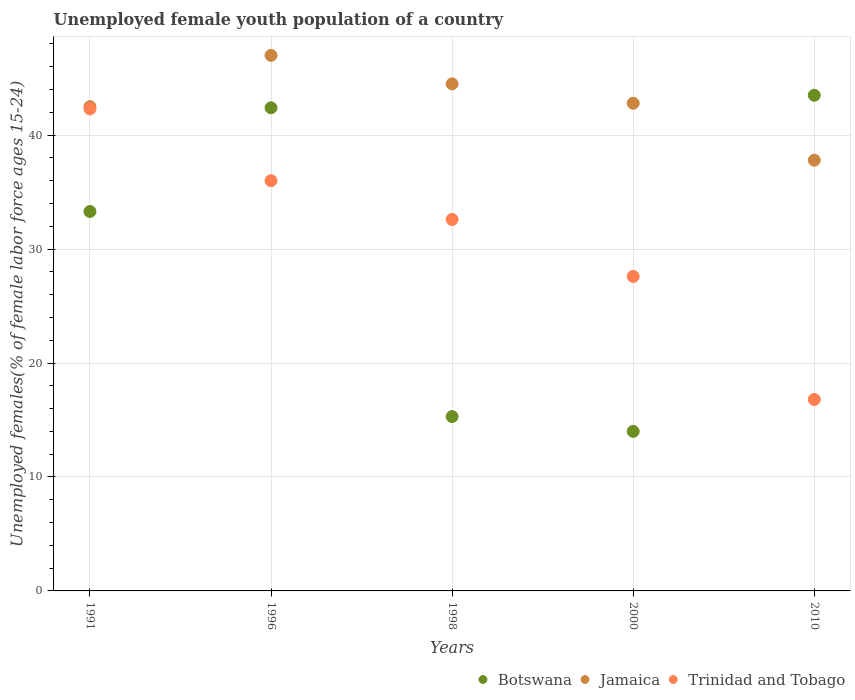Is the number of dotlines equal to the number of legend labels?
Offer a terse response. Yes. Across all years, what is the maximum percentage of unemployed female youth population in Jamaica?
Your answer should be compact. 47. Across all years, what is the minimum percentage of unemployed female youth population in Jamaica?
Your answer should be very brief. 37.8. What is the total percentage of unemployed female youth population in Trinidad and Tobago in the graph?
Your response must be concise. 155.3. What is the difference between the percentage of unemployed female youth population in Botswana in 1991 and that in 1996?
Offer a terse response. -9.1. What is the difference between the percentage of unemployed female youth population in Jamaica in 2000 and the percentage of unemployed female youth population in Botswana in 1996?
Your answer should be compact. 0.4. What is the average percentage of unemployed female youth population in Jamaica per year?
Offer a very short reply. 42.92. In the year 2010, what is the difference between the percentage of unemployed female youth population in Jamaica and percentage of unemployed female youth population in Trinidad and Tobago?
Offer a very short reply. 21. In how many years, is the percentage of unemployed female youth population in Jamaica greater than 20 %?
Your answer should be very brief. 5. What is the ratio of the percentage of unemployed female youth population in Jamaica in 1991 to that in 1996?
Your answer should be very brief. 0.9. Is the difference between the percentage of unemployed female youth population in Jamaica in 1998 and 2000 greater than the difference between the percentage of unemployed female youth population in Trinidad and Tobago in 1998 and 2000?
Your answer should be very brief. No. What is the difference between the highest and the second highest percentage of unemployed female youth population in Botswana?
Give a very brief answer. 1.1. What is the difference between the highest and the lowest percentage of unemployed female youth population in Botswana?
Your answer should be very brief. 29.5. In how many years, is the percentage of unemployed female youth population in Botswana greater than the average percentage of unemployed female youth population in Botswana taken over all years?
Offer a terse response. 3. Is the sum of the percentage of unemployed female youth population in Jamaica in 1996 and 1998 greater than the maximum percentage of unemployed female youth population in Trinidad and Tobago across all years?
Your response must be concise. Yes. Is it the case that in every year, the sum of the percentage of unemployed female youth population in Jamaica and percentage of unemployed female youth population in Trinidad and Tobago  is greater than the percentage of unemployed female youth population in Botswana?
Provide a succinct answer. Yes. How many dotlines are there?
Keep it short and to the point. 3. How many years are there in the graph?
Offer a very short reply. 5. What is the difference between two consecutive major ticks on the Y-axis?
Provide a succinct answer. 10. Does the graph contain any zero values?
Provide a short and direct response. No. What is the title of the graph?
Make the answer very short. Unemployed female youth population of a country. What is the label or title of the X-axis?
Provide a short and direct response. Years. What is the label or title of the Y-axis?
Keep it short and to the point. Unemployed females(% of female labor force ages 15-24). What is the Unemployed females(% of female labor force ages 15-24) of Botswana in 1991?
Provide a succinct answer. 33.3. What is the Unemployed females(% of female labor force ages 15-24) in Jamaica in 1991?
Ensure brevity in your answer.  42.5. What is the Unemployed females(% of female labor force ages 15-24) of Trinidad and Tobago in 1991?
Your response must be concise. 42.3. What is the Unemployed females(% of female labor force ages 15-24) in Botswana in 1996?
Offer a very short reply. 42.4. What is the Unemployed females(% of female labor force ages 15-24) in Jamaica in 1996?
Your answer should be very brief. 47. What is the Unemployed females(% of female labor force ages 15-24) in Trinidad and Tobago in 1996?
Make the answer very short. 36. What is the Unemployed females(% of female labor force ages 15-24) in Botswana in 1998?
Keep it short and to the point. 15.3. What is the Unemployed females(% of female labor force ages 15-24) in Jamaica in 1998?
Make the answer very short. 44.5. What is the Unemployed females(% of female labor force ages 15-24) of Trinidad and Tobago in 1998?
Offer a very short reply. 32.6. What is the Unemployed females(% of female labor force ages 15-24) in Jamaica in 2000?
Make the answer very short. 42.8. What is the Unemployed females(% of female labor force ages 15-24) of Trinidad and Tobago in 2000?
Offer a terse response. 27.6. What is the Unemployed females(% of female labor force ages 15-24) in Botswana in 2010?
Provide a short and direct response. 43.5. What is the Unemployed females(% of female labor force ages 15-24) in Jamaica in 2010?
Offer a very short reply. 37.8. What is the Unemployed females(% of female labor force ages 15-24) of Trinidad and Tobago in 2010?
Make the answer very short. 16.8. Across all years, what is the maximum Unemployed females(% of female labor force ages 15-24) in Botswana?
Give a very brief answer. 43.5. Across all years, what is the maximum Unemployed females(% of female labor force ages 15-24) in Jamaica?
Ensure brevity in your answer.  47. Across all years, what is the maximum Unemployed females(% of female labor force ages 15-24) in Trinidad and Tobago?
Your answer should be very brief. 42.3. Across all years, what is the minimum Unemployed females(% of female labor force ages 15-24) of Jamaica?
Offer a terse response. 37.8. Across all years, what is the minimum Unemployed females(% of female labor force ages 15-24) in Trinidad and Tobago?
Your response must be concise. 16.8. What is the total Unemployed females(% of female labor force ages 15-24) in Botswana in the graph?
Your response must be concise. 148.5. What is the total Unemployed females(% of female labor force ages 15-24) of Jamaica in the graph?
Your answer should be very brief. 214.6. What is the total Unemployed females(% of female labor force ages 15-24) of Trinidad and Tobago in the graph?
Ensure brevity in your answer.  155.3. What is the difference between the Unemployed females(% of female labor force ages 15-24) of Jamaica in 1991 and that in 1998?
Provide a short and direct response. -2. What is the difference between the Unemployed females(% of female labor force ages 15-24) of Botswana in 1991 and that in 2000?
Make the answer very short. 19.3. What is the difference between the Unemployed females(% of female labor force ages 15-24) of Botswana in 1991 and that in 2010?
Ensure brevity in your answer.  -10.2. What is the difference between the Unemployed females(% of female labor force ages 15-24) in Botswana in 1996 and that in 1998?
Ensure brevity in your answer.  27.1. What is the difference between the Unemployed females(% of female labor force ages 15-24) in Jamaica in 1996 and that in 1998?
Your answer should be compact. 2.5. What is the difference between the Unemployed females(% of female labor force ages 15-24) of Botswana in 1996 and that in 2000?
Make the answer very short. 28.4. What is the difference between the Unemployed females(% of female labor force ages 15-24) in Botswana in 1996 and that in 2010?
Offer a very short reply. -1.1. What is the difference between the Unemployed females(% of female labor force ages 15-24) of Jamaica in 1996 and that in 2010?
Offer a very short reply. 9.2. What is the difference between the Unemployed females(% of female labor force ages 15-24) in Botswana in 1998 and that in 2000?
Provide a short and direct response. 1.3. What is the difference between the Unemployed females(% of female labor force ages 15-24) of Trinidad and Tobago in 1998 and that in 2000?
Your answer should be very brief. 5. What is the difference between the Unemployed females(% of female labor force ages 15-24) in Botswana in 1998 and that in 2010?
Make the answer very short. -28.2. What is the difference between the Unemployed females(% of female labor force ages 15-24) in Jamaica in 1998 and that in 2010?
Keep it short and to the point. 6.7. What is the difference between the Unemployed females(% of female labor force ages 15-24) in Trinidad and Tobago in 1998 and that in 2010?
Your response must be concise. 15.8. What is the difference between the Unemployed females(% of female labor force ages 15-24) in Botswana in 2000 and that in 2010?
Keep it short and to the point. -29.5. What is the difference between the Unemployed females(% of female labor force ages 15-24) of Jamaica in 2000 and that in 2010?
Your answer should be compact. 5. What is the difference between the Unemployed females(% of female labor force ages 15-24) of Trinidad and Tobago in 2000 and that in 2010?
Keep it short and to the point. 10.8. What is the difference between the Unemployed females(% of female labor force ages 15-24) of Botswana in 1991 and the Unemployed females(% of female labor force ages 15-24) of Jamaica in 1996?
Provide a short and direct response. -13.7. What is the difference between the Unemployed females(% of female labor force ages 15-24) in Botswana in 1991 and the Unemployed females(% of female labor force ages 15-24) in Jamaica in 1998?
Provide a short and direct response. -11.2. What is the difference between the Unemployed females(% of female labor force ages 15-24) of Botswana in 1991 and the Unemployed females(% of female labor force ages 15-24) of Trinidad and Tobago in 1998?
Offer a terse response. 0.7. What is the difference between the Unemployed females(% of female labor force ages 15-24) in Jamaica in 1991 and the Unemployed females(% of female labor force ages 15-24) in Trinidad and Tobago in 1998?
Provide a succinct answer. 9.9. What is the difference between the Unemployed females(% of female labor force ages 15-24) of Jamaica in 1991 and the Unemployed females(% of female labor force ages 15-24) of Trinidad and Tobago in 2000?
Offer a very short reply. 14.9. What is the difference between the Unemployed females(% of female labor force ages 15-24) in Botswana in 1991 and the Unemployed females(% of female labor force ages 15-24) in Jamaica in 2010?
Your answer should be compact. -4.5. What is the difference between the Unemployed females(% of female labor force ages 15-24) in Jamaica in 1991 and the Unemployed females(% of female labor force ages 15-24) in Trinidad and Tobago in 2010?
Your answer should be compact. 25.7. What is the difference between the Unemployed females(% of female labor force ages 15-24) of Botswana in 1996 and the Unemployed females(% of female labor force ages 15-24) of Jamaica in 2000?
Offer a very short reply. -0.4. What is the difference between the Unemployed females(% of female labor force ages 15-24) in Botswana in 1996 and the Unemployed females(% of female labor force ages 15-24) in Trinidad and Tobago in 2010?
Give a very brief answer. 25.6. What is the difference between the Unemployed females(% of female labor force ages 15-24) in Jamaica in 1996 and the Unemployed females(% of female labor force ages 15-24) in Trinidad and Tobago in 2010?
Ensure brevity in your answer.  30.2. What is the difference between the Unemployed females(% of female labor force ages 15-24) in Botswana in 1998 and the Unemployed females(% of female labor force ages 15-24) in Jamaica in 2000?
Your answer should be very brief. -27.5. What is the difference between the Unemployed females(% of female labor force ages 15-24) in Botswana in 1998 and the Unemployed females(% of female labor force ages 15-24) in Jamaica in 2010?
Your answer should be very brief. -22.5. What is the difference between the Unemployed females(% of female labor force ages 15-24) in Botswana in 1998 and the Unemployed females(% of female labor force ages 15-24) in Trinidad and Tobago in 2010?
Your answer should be very brief. -1.5. What is the difference between the Unemployed females(% of female labor force ages 15-24) in Jamaica in 1998 and the Unemployed females(% of female labor force ages 15-24) in Trinidad and Tobago in 2010?
Provide a short and direct response. 27.7. What is the difference between the Unemployed females(% of female labor force ages 15-24) of Botswana in 2000 and the Unemployed females(% of female labor force ages 15-24) of Jamaica in 2010?
Provide a short and direct response. -23.8. What is the difference between the Unemployed females(% of female labor force ages 15-24) of Botswana in 2000 and the Unemployed females(% of female labor force ages 15-24) of Trinidad and Tobago in 2010?
Ensure brevity in your answer.  -2.8. What is the difference between the Unemployed females(% of female labor force ages 15-24) in Jamaica in 2000 and the Unemployed females(% of female labor force ages 15-24) in Trinidad and Tobago in 2010?
Ensure brevity in your answer.  26. What is the average Unemployed females(% of female labor force ages 15-24) of Botswana per year?
Your answer should be very brief. 29.7. What is the average Unemployed females(% of female labor force ages 15-24) of Jamaica per year?
Keep it short and to the point. 42.92. What is the average Unemployed females(% of female labor force ages 15-24) of Trinidad and Tobago per year?
Your answer should be very brief. 31.06. In the year 1991, what is the difference between the Unemployed females(% of female labor force ages 15-24) of Botswana and Unemployed females(% of female labor force ages 15-24) of Jamaica?
Keep it short and to the point. -9.2. In the year 1991, what is the difference between the Unemployed females(% of female labor force ages 15-24) of Botswana and Unemployed females(% of female labor force ages 15-24) of Trinidad and Tobago?
Provide a short and direct response. -9. In the year 1991, what is the difference between the Unemployed females(% of female labor force ages 15-24) of Jamaica and Unemployed females(% of female labor force ages 15-24) of Trinidad and Tobago?
Provide a short and direct response. 0.2. In the year 1996, what is the difference between the Unemployed females(% of female labor force ages 15-24) in Botswana and Unemployed females(% of female labor force ages 15-24) in Trinidad and Tobago?
Your response must be concise. 6.4. In the year 1998, what is the difference between the Unemployed females(% of female labor force ages 15-24) in Botswana and Unemployed females(% of female labor force ages 15-24) in Jamaica?
Make the answer very short. -29.2. In the year 1998, what is the difference between the Unemployed females(% of female labor force ages 15-24) of Botswana and Unemployed females(% of female labor force ages 15-24) of Trinidad and Tobago?
Keep it short and to the point. -17.3. In the year 2000, what is the difference between the Unemployed females(% of female labor force ages 15-24) of Botswana and Unemployed females(% of female labor force ages 15-24) of Jamaica?
Your answer should be very brief. -28.8. In the year 2000, what is the difference between the Unemployed females(% of female labor force ages 15-24) of Botswana and Unemployed females(% of female labor force ages 15-24) of Trinidad and Tobago?
Your answer should be compact. -13.6. In the year 2010, what is the difference between the Unemployed females(% of female labor force ages 15-24) in Botswana and Unemployed females(% of female labor force ages 15-24) in Trinidad and Tobago?
Offer a very short reply. 26.7. In the year 2010, what is the difference between the Unemployed females(% of female labor force ages 15-24) in Jamaica and Unemployed females(% of female labor force ages 15-24) in Trinidad and Tobago?
Give a very brief answer. 21. What is the ratio of the Unemployed females(% of female labor force ages 15-24) in Botswana in 1991 to that in 1996?
Offer a very short reply. 0.79. What is the ratio of the Unemployed females(% of female labor force ages 15-24) of Jamaica in 1991 to that in 1996?
Make the answer very short. 0.9. What is the ratio of the Unemployed females(% of female labor force ages 15-24) in Trinidad and Tobago in 1991 to that in 1996?
Give a very brief answer. 1.18. What is the ratio of the Unemployed females(% of female labor force ages 15-24) of Botswana in 1991 to that in 1998?
Your answer should be compact. 2.18. What is the ratio of the Unemployed females(% of female labor force ages 15-24) in Jamaica in 1991 to that in 1998?
Provide a succinct answer. 0.96. What is the ratio of the Unemployed females(% of female labor force ages 15-24) of Trinidad and Tobago in 1991 to that in 1998?
Keep it short and to the point. 1.3. What is the ratio of the Unemployed females(% of female labor force ages 15-24) of Botswana in 1991 to that in 2000?
Offer a terse response. 2.38. What is the ratio of the Unemployed females(% of female labor force ages 15-24) in Jamaica in 1991 to that in 2000?
Make the answer very short. 0.99. What is the ratio of the Unemployed females(% of female labor force ages 15-24) of Trinidad and Tobago in 1991 to that in 2000?
Provide a succinct answer. 1.53. What is the ratio of the Unemployed females(% of female labor force ages 15-24) in Botswana in 1991 to that in 2010?
Make the answer very short. 0.77. What is the ratio of the Unemployed females(% of female labor force ages 15-24) of Jamaica in 1991 to that in 2010?
Offer a very short reply. 1.12. What is the ratio of the Unemployed females(% of female labor force ages 15-24) of Trinidad and Tobago in 1991 to that in 2010?
Offer a very short reply. 2.52. What is the ratio of the Unemployed females(% of female labor force ages 15-24) in Botswana in 1996 to that in 1998?
Offer a terse response. 2.77. What is the ratio of the Unemployed females(% of female labor force ages 15-24) in Jamaica in 1996 to that in 1998?
Give a very brief answer. 1.06. What is the ratio of the Unemployed females(% of female labor force ages 15-24) of Trinidad and Tobago in 1996 to that in 1998?
Offer a terse response. 1.1. What is the ratio of the Unemployed females(% of female labor force ages 15-24) of Botswana in 1996 to that in 2000?
Give a very brief answer. 3.03. What is the ratio of the Unemployed females(% of female labor force ages 15-24) in Jamaica in 1996 to that in 2000?
Ensure brevity in your answer.  1.1. What is the ratio of the Unemployed females(% of female labor force ages 15-24) of Trinidad and Tobago in 1996 to that in 2000?
Offer a terse response. 1.3. What is the ratio of the Unemployed females(% of female labor force ages 15-24) in Botswana in 1996 to that in 2010?
Your answer should be compact. 0.97. What is the ratio of the Unemployed females(% of female labor force ages 15-24) in Jamaica in 1996 to that in 2010?
Provide a succinct answer. 1.24. What is the ratio of the Unemployed females(% of female labor force ages 15-24) in Trinidad and Tobago in 1996 to that in 2010?
Your answer should be compact. 2.14. What is the ratio of the Unemployed females(% of female labor force ages 15-24) in Botswana in 1998 to that in 2000?
Your response must be concise. 1.09. What is the ratio of the Unemployed females(% of female labor force ages 15-24) in Jamaica in 1998 to that in 2000?
Offer a terse response. 1.04. What is the ratio of the Unemployed females(% of female labor force ages 15-24) in Trinidad and Tobago in 1998 to that in 2000?
Your answer should be very brief. 1.18. What is the ratio of the Unemployed females(% of female labor force ages 15-24) of Botswana in 1998 to that in 2010?
Keep it short and to the point. 0.35. What is the ratio of the Unemployed females(% of female labor force ages 15-24) in Jamaica in 1998 to that in 2010?
Provide a succinct answer. 1.18. What is the ratio of the Unemployed females(% of female labor force ages 15-24) of Trinidad and Tobago in 1998 to that in 2010?
Ensure brevity in your answer.  1.94. What is the ratio of the Unemployed females(% of female labor force ages 15-24) of Botswana in 2000 to that in 2010?
Your response must be concise. 0.32. What is the ratio of the Unemployed females(% of female labor force ages 15-24) of Jamaica in 2000 to that in 2010?
Your response must be concise. 1.13. What is the ratio of the Unemployed females(% of female labor force ages 15-24) of Trinidad and Tobago in 2000 to that in 2010?
Keep it short and to the point. 1.64. What is the difference between the highest and the second highest Unemployed females(% of female labor force ages 15-24) of Jamaica?
Keep it short and to the point. 2.5. What is the difference between the highest and the lowest Unemployed females(% of female labor force ages 15-24) of Botswana?
Offer a terse response. 29.5. What is the difference between the highest and the lowest Unemployed females(% of female labor force ages 15-24) in Trinidad and Tobago?
Your answer should be compact. 25.5. 